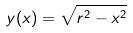Convert formula to latex. <formula><loc_0><loc_0><loc_500><loc_500>y ( x ) = \sqrt { r ^ { 2 } - x ^ { 2 } }</formula> 